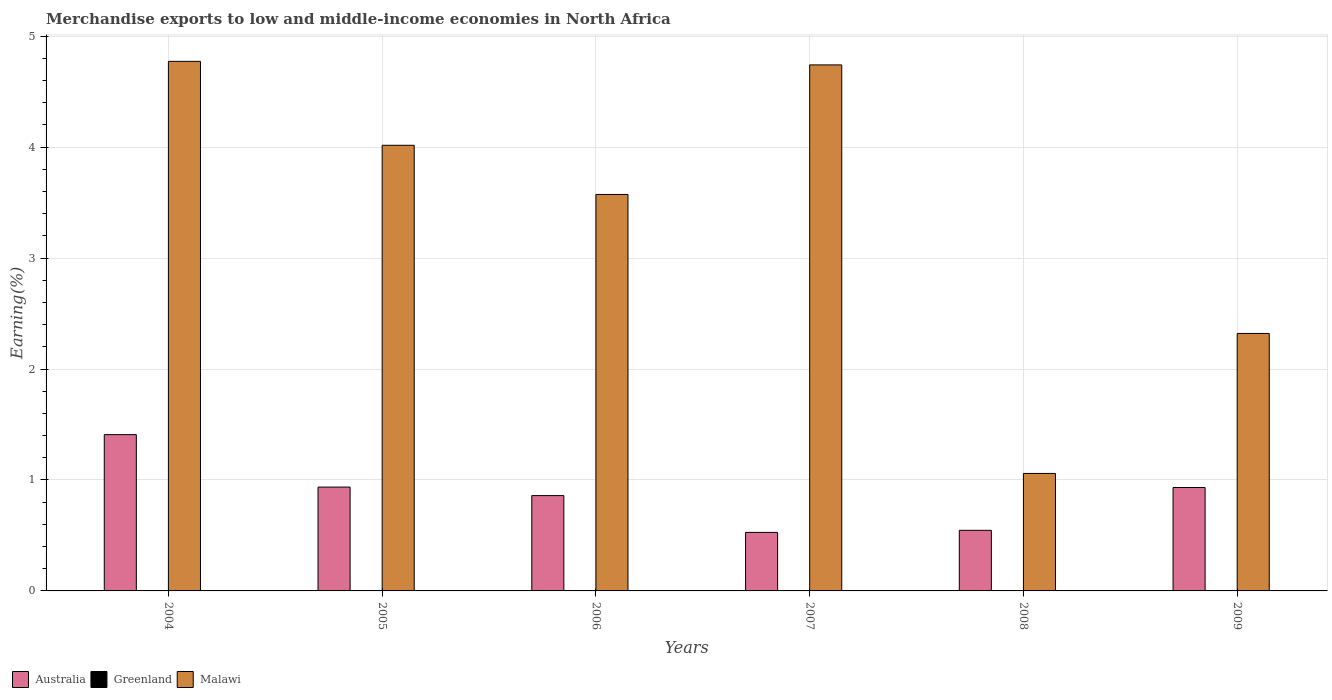Are the number of bars per tick equal to the number of legend labels?
Keep it short and to the point. Yes. Are the number of bars on each tick of the X-axis equal?
Make the answer very short. Yes. In how many cases, is the number of bars for a given year not equal to the number of legend labels?
Give a very brief answer. 0. What is the percentage of amount earned from merchandise exports in Greenland in 2004?
Keep it short and to the point. 2.789635339457349e-5. Across all years, what is the maximum percentage of amount earned from merchandise exports in Australia?
Make the answer very short. 1.41. Across all years, what is the minimum percentage of amount earned from merchandise exports in Greenland?
Make the answer very short. 2.789635339457349e-5. In which year was the percentage of amount earned from merchandise exports in Malawi minimum?
Ensure brevity in your answer.  2008. What is the total percentage of amount earned from merchandise exports in Greenland in the graph?
Provide a short and direct response. 0. What is the difference between the percentage of amount earned from merchandise exports in Malawi in 2008 and that in 2009?
Your response must be concise. -1.26. What is the difference between the percentage of amount earned from merchandise exports in Australia in 2005 and the percentage of amount earned from merchandise exports in Greenland in 2006?
Offer a terse response. 0.94. What is the average percentage of amount earned from merchandise exports in Greenland per year?
Offer a terse response. 0. In the year 2006, what is the difference between the percentage of amount earned from merchandise exports in Australia and percentage of amount earned from merchandise exports in Greenland?
Provide a short and direct response. 0.86. What is the ratio of the percentage of amount earned from merchandise exports in Australia in 2005 to that in 2006?
Your response must be concise. 1.09. What is the difference between the highest and the second highest percentage of amount earned from merchandise exports in Australia?
Offer a terse response. 0.47. What is the difference between the highest and the lowest percentage of amount earned from merchandise exports in Greenland?
Offer a very short reply. 0. In how many years, is the percentage of amount earned from merchandise exports in Malawi greater than the average percentage of amount earned from merchandise exports in Malawi taken over all years?
Your answer should be compact. 4. What does the 1st bar from the left in 2008 represents?
Your response must be concise. Australia. What does the 1st bar from the right in 2009 represents?
Your response must be concise. Malawi. Is it the case that in every year, the sum of the percentage of amount earned from merchandise exports in Malawi and percentage of amount earned from merchandise exports in Australia is greater than the percentage of amount earned from merchandise exports in Greenland?
Your response must be concise. Yes. Are all the bars in the graph horizontal?
Your answer should be compact. No. What is the difference between two consecutive major ticks on the Y-axis?
Your answer should be compact. 1. Are the values on the major ticks of Y-axis written in scientific E-notation?
Your response must be concise. No. Does the graph contain grids?
Your answer should be very brief. Yes. Where does the legend appear in the graph?
Ensure brevity in your answer.  Bottom left. What is the title of the graph?
Your answer should be very brief. Merchandise exports to low and middle-income economies in North Africa. What is the label or title of the Y-axis?
Provide a succinct answer. Earning(%). What is the Earning(%) in Australia in 2004?
Give a very brief answer. 1.41. What is the Earning(%) in Greenland in 2004?
Your answer should be compact. 2.789635339457349e-5. What is the Earning(%) in Malawi in 2004?
Offer a terse response. 4.77. What is the Earning(%) of Australia in 2005?
Ensure brevity in your answer.  0.94. What is the Earning(%) in Greenland in 2005?
Ensure brevity in your answer.  0. What is the Earning(%) in Malawi in 2005?
Keep it short and to the point. 4.02. What is the Earning(%) of Australia in 2006?
Your answer should be compact. 0.86. What is the Earning(%) of Greenland in 2006?
Offer a very short reply. 0. What is the Earning(%) of Malawi in 2006?
Offer a very short reply. 3.57. What is the Earning(%) of Australia in 2007?
Your response must be concise. 0.53. What is the Earning(%) of Greenland in 2007?
Your answer should be compact. 0. What is the Earning(%) of Malawi in 2007?
Provide a short and direct response. 4.74. What is the Earning(%) of Australia in 2008?
Offer a terse response. 0.55. What is the Earning(%) of Greenland in 2008?
Offer a very short reply. 0. What is the Earning(%) of Malawi in 2008?
Keep it short and to the point. 1.06. What is the Earning(%) of Australia in 2009?
Your response must be concise. 0.93. What is the Earning(%) in Greenland in 2009?
Offer a terse response. 0. What is the Earning(%) in Malawi in 2009?
Offer a very short reply. 2.32. Across all years, what is the maximum Earning(%) in Australia?
Offer a terse response. 1.41. Across all years, what is the maximum Earning(%) in Greenland?
Your answer should be compact. 0. Across all years, what is the maximum Earning(%) in Malawi?
Provide a short and direct response. 4.77. Across all years, what is the minimum Earning(%) in Australia?
Offer a terse response. 0.53. Across all years, what is the minimum Earning(%) of Greenland?
Give a very brief answer. 2.789635339457349e-5. Across all years, what is the minimum Earning(%) in Malawi?
Keep it short and to the point. 1.06. What is the total Earning(%) of Australia in the graph?
Your answer should be very brief. 5.21. What is the total Earning(%) in Greenland in the graph?
Give a very brief answer. 0. What is the total Earning(%) of Malawi in the graph?
Make the answer very short. 20.49. What is the difference between the Earning(%) of Australia in 2004 and that in 2005?
Offer a very short reply. 0.47. What is the difference between the Earning(%) in Greenland in 2004 and that in 2005?
Your answer should be compact. -0. What is the difference between the Earning(%) of Malawi in 2004 and that in 2005?
Your answer should be compact. 0.76. What is the difference between the Earning(%) of Australia in 2004 and that in 2006?
Make the answer very short. 0.55. What is the difference between the Earning(%) in Greenland in 2004 and that in 2006?
Offer a terse response. -0. What is the difference between the Earning(%) of Malawi in 2004 and that in 2006?
Your answer should be very brief. 1.2. What is the difference between the Earning(%) in Australia in 2004 and that in 2007?
Give a very brief answer. 0.88. What is the difference between the Earning(%) of Greenland in 2004 and that in 2007?
Provide a succinct answer. -0. What is the difference between the Earning(%) of Malawi in 2004 and that in 2007?
Ensure brevity in your answer.  0.03. What is the difference between the Earning(%) of Australia in 2004 and that in 2008?
Provide a succinct answer. 0.86. What is the difference between the Earning(%) of Greenland in 2004 and that in 2008?
Ensure brevity in your answer.  -0. What is the difference between the Earning(%) in Malawi in 2004 and that in 2008?
Make the answer very short. 3.71. What is the difference between the Earning(%) of Australia in 2004 and that in 2009?
Offer a very short reply. 0.48. What is the difference between the Earning(%) of Greenland in 2004 and that in 2009?
Your answer should be very brief. -0. What is the difference between the Earning(%) in Malawi in 2004 and that in 2009?
Offer a very short reply. 2.45. What is the difference between the Earning(%) of Australia in 2005 and that in 2006?
Your response must be concise. 0.08. What is the difference between the Earning(%) of Greenland in 2005 and that in 2006?
Give a very brief answer. 0. What is the difference between the Earning(%) of Malawi in 2005 and that in 2006?
Your answer should be compact. 0.44. What is the difference between the Earning(%) of Australia in 2005 and that in 2007?
Your answer should be compact. 0.41. What is the difference between the Earning(%) of Greenland in 2005 and that in 2007?
Ensure brevity in your answer.  0. What is the difference between the Earning(%) of Malawi in 2005 and that in 2007?
Make the answer very short. -0.72. What is the difference between the Earning(%) of Australia in 2005 and that in 2008?
Your response must be concise. 0.39. What is the difference between the Earning(%) of Greenland in 2005 and that in 2008?
Offer a terse response. 0. What is the difference between the Earning(%) of Malawi in 2005 and that in 2008?
Offer a terse response. 2.96. What is the difference between the Earning(%) in Australia in 2005 and that in 2009?
Your answer should be very brief. 0. What is the difference between the Earning(%) of Greenland in 2005 and that in 2009?
Provide a short and direct response. 0. What is the difference between the Earning(%) in Malawi in 2005 and that in 2009?
Your answer should be compact. 1.7. What is the difference between the Earning(%) in Australia in 2006 and that in 2007?
Give a very brief answer. 0.33. What is the difference between the Earning(%) of Greenland in 2006 and that in 2007?
Your response must be concise. 0. What is the difference between the Earning(%) of Malawi in 2006 and that in 2007?
Keep it short and to the point. -1.17. What is the difference between the Earning(%) of Australia in 2006 and that in 2008?
Your answer should be very brief. 0.31. What is the difference between the Earning(%) of Greenland in 2006 and that in 2008?
Ensure brevity in your answer.  0. What is the difference between the Earning(%) of Malawi in 2006 and that in 2008?
Provide a succinct answer. 2.51. What is the difference between the Earning(%) in Australia in 2006 and that in 2009?
Offer a very short reply. -0.07. What is the difference between the Earning(%) of Malawi in 2006 and that in 2009?
Offer a terse response. 1.25. What is the difference between the Earning(%) of Australia in 2007 and that in 2008?
Provide a short and direct response. -0.02. What is the difference between the Earning(%) of Malawi in 2007 and that in 2008?
Offer a terse response. 3.68. What is the difference between the Earning(%) in Australia in 2007 and that in 2009?
Offer a terse response. -0.4. What is the difference between the Earning(%) in Malawi in 2007 and that in 2009?
Give a very brief answer. 2.42. What is the difference between the Earning(%) of Australia in 2008 and that in 2009?
Your answer should be compact. -0.39. What is the difference between the Earning(%) in Malawi in 2008 and that in 2009?
Your answer should be compact. -1.26. What is the difference between the Earning(%) in Australia in 2004 and the Earning(%) in Greenland in 2005?
Provide a short and direct response. 1.41. What is the difference between the Earning(%) in Australia in 2004 and the Earning(%) in Malawi in 2005?
Ensure brevity in your answer.  -2.61. What is the difference between the Earning(%) in Greenland in 2004 and the Earning(%) in Malawi in 2005?
Offer a very short reply. -4.02. What is the difference between the Earning(%) of Australia in 2004 and the Earning(%) of Greenland in 2006?
Your answer should be very brief. 1.41. What is the difference between the Earning(%) in Australia in 2004 and the Earning(%) in Malawi in 2006?
Offer a very short reply. -2.16. What is the difference between the Earning(%) of Greenland in 2004 and the Earning(%) of Malawi in 2006?
Your answer should be compact. -3.57. What is the difference between the Earning(%) of Australia in 2004 and the Earning(%) of Greenland in 2007?
Your answer should be compact. 1.41. What is the difference between the Earning(%) of Australia in 2004 and the Earning(%) of Malawi in 2007?
Provide a succinct answer. -3.33. What is the difference between the Earning(%) of Greenland in 2004 and the Earning(%) of Malawi in 2007?
Make the answer very short. -4.74. What is the difference between the Earning(%) in Australia in 2004 and the Earning(%) in Greenland in 2008?
Provide a short and direct response. 1.41. What is the difference between the Earning(%) in Australia in 2004 and the Earning(%) in Malawi in 2008?
Give a very brief answer. 0.35. What is the difference between the Earning(%) in Greenland in 2004 and the Earning(%) in Malawi in 2008?
Ensure brevity in your answer.  -1.06. What is the difference between the Earning(%) of Australia in 2004 and the Earning(%) of Greenland in 2009?
Offer a very short reply. 1.41. What is the difference between the Earning(%) of Australia in 2004 and the Earning(%) of Malawi in 2009?
Your response must be concise. -0.91. What is the difference between the Earning(%) in Greenland in 2004 and the Earning(%) in Malawi in 2009?
Make the answer very short. -2.32. What is the difference between the Earning(%) of Australia in 2005 and the Earning(%) of Greenland in 2006?
Make the answer very short. 0.94. What is the difference between the Earning(%) in Australia in 2005 and the Earning(%) in Malawi in 2006?
Make the answer very short. -2.64. What is the difference between the Earning(%) in Greenland in 2005 and the Earning(%) in Malawi in 2006?
Offer a terse response. -3.57. What is the difference between the Earning(%) in Australia in 2005 and the Earning(%) in Greenland in 2007?
Provide a succinct answer. 0.94. What is the difference between the Earning(%) of Australia in 2005 and the Earning(%) of Malawi in 2007?
Ensure brevity in your answer.  -3.81. What is the difference between the Earning(%) in Greenland in 2005 and the Earning(%) in Malawi in 2007?
Offer a very short reply. -4.74. What is the difference between the Earning(%) in Australia in 2005 and the Earning(%) in Greenland in 2008?
Give a very brief answer. 0.94. What is the difference between the Earning(%) in Australia in 2005 and the Earning(%) in Malawi in 2008?
Offer a terse response. -0.12. What is the difference between the Earning(%) of Greenland in 2005 and the Earning(%) of Malawi in 2008?
Your answer should be very brief. -1.06. What is the difference between the Earning(%) of Australia in 2005 and the Earning(%) of Greenland in 2009?
Keep it short and to the point. 0.94. What is the difference between the Earning(%) in Australia in 2005 and the Earning(%) in Malawi in 2009?
Your response must be concise. -1.38. What is the difference between the Earning(%) of Greenland in 2005 and the Earning(%) of Malawi in 2009?
Ensure brevity in your answer.  -2.32. What is the difference between the Earning(%) in Australia in 2006 and the Earning(%) in Greenland in 2007?
Offer a very short reply. 0.86. What is the difference between the Earning(%) of Australia in 2006 and the Earning(%) of Malawi in 2007?
Offer a terse response. -3.88. What is the difference between the Earning(%) of Greenland in 2006 and the Earning(%) of Malawi in 2007?
Make the answer very short. -4.74. What is the difference between the Earning(%) in Australia in 2006 and the Earning(%) in Greenland in 2008?
Provide a short and direct response. 0.86. What is the difference between the Earning(%) in Australia in 2006 and the Earning(%) in Malawi in 2008?
Offer a very short reply. -0.2. What is the difference between the Earning(%) in Greenland in 2006 and the Earning(%) in Malawi in 2008?
Keep it short and to the point. -1.06. What is the difference between the Earning(%) in Australia in 2006 and the Earning(%) in Greenland in 2009?
Your response must be concise. 0.86. What is the difference between the Earning(%) of Australia in 2006 and the Earning(%) of Malawi in 2009?
Keep it short and to the point. -1.46. What is the difference between the Earning(%) in Greenland in 2006 and the Earning(%) in Malawi in 2009?
Offer a terse response. -2.32. What is the difference between the Earning(%) of Australia in 2007 and the Earning(%) of Greenland in 2008?
Offer a very short reply. 0.53. What is the difference between the Earning(%) of Australia in 2007 and the Earning(%) of Malawi in 2008?
Offer a very short reply. -0.53. What is the difference between the Earning(%) in Greenland in 2007 and the Earning(%) in Malawi in 2008?
Your response must be concise. -1.06. What is the difference between the Earning(%) in Australia in 2007 and the Earning(%) in Greenland in 2009?
Give a very brief answer. 0.53. What is the difference between the Earning(%) of Australia in 2007 and the Earning(%) of Malawi in 2009?
Offer a very short reply. -1.79. What is the difference between the Earning(%) in Greenland in 2007 and the Earning(%) in Malawi in 2009?
Offer a very short reply. -2.32. What is the difference between the Earning(%) in Australia in 2008 and the Earning(%) in Greenland in 2009?
Keep it short and to the point. 0.55. What is the difference between the Earning(%) in Australia in 2008 and the Earning(%) in Malawi in 2009?
Give a very brief answer. -1.77. What is the difference between the Earning(%) in Greenland in 2008 and the Earning(%) in Malawi in 2009?
Your answer should be compact. -2.32. What is the average Earning(%) in Australia per year?
Provide a short and direct response. 0.87. What is the average Earning(%) in Greenland per year?
Provide a short and direct response. 0. What is the average Earning(%) of Malawi per year?
Give a very brief answer. 3.41. In the year 2004, what is the difference between the Earning(%) of Australia and Earning(%) of Greenland?
Offer a terse response. 1.41. In the year 2004, what is the difference between the Earning(%) in Australia and Earning(%) in Malawi?
Give a very brief answer. -3.36. In the year 2004, what is the difference between the Earning(%) in Greenland and Earning(%) in Malawi?
Offer a very short reply. -4.77. In the year 2005, what is the difference between the Earning(%) in Australia and Earning(%) in Greenland?
Ensure brevity in your answer.  0.94. In the year 2005, what is the difference between the Earning(%) of Australia and Earning(%) of Malawi?
Provide a short and direct response. -3.08. In the year 2005, what is the difference between the Earning(%) in Greenland and Earning(%) in Malawi?
Your response must be concise. -4.02. In the year 2006, what is the difference between the Earning(%) of Australia and Earning(%) of Greenland?
Your answer should be very brief. 0.86. In the year 2006, what is the difference between the Earning(%) of Australia and Earning(%) of Malawi?
Give a very brief answer. -2.71. In the year 2006, what is the difference between the Earning(%) in Greenland and Earning(%) in Malawi?
Offer a very short reply. -3.57. In the year 2007, what is the difference between the Earning(%) in Australia and Earning(%) in Greenland?
Keep it short and to the point. 0.53. In the year 2007, what is the difference between the Earning(%) of Australia and Earning(%) of Malawi?
Keep it short and to the point. -4.21. In the year 2007, what is the difference between the Earning(%) in Greenland and Earning(%) in Malawi?
Provide a succinct answer. -4.74. In the year 2008, what is the difference between the Earning(%) of Australia and Earning(%) of Greenland?
Your answer should be compact. 0.55. In the year 2008, what is the difference between the Earning(%) of Australia and Earning(%) of Malawi?
Offer a very short reply. -0.51. In the year 2008, what is the difference between the Earning(%) of Greenland and Earning(%) of Malawi?
Give a very brief answer. -1.06. In the year 2009, what is the difference between the Earning(%) of Australia and Earning(%) of Greenland?
Offer a terse response. 0.93. In the year 2009, what is the difference between the Earning(%) of Australia and Earning(%) of Malawi?
Your response must be concise. -1.39. In the year 2009, what is the difference between the Earning(%) of Greenland and Earning(%) of Malawi?
Your answer should be compact. -2.32. What is the ratio of the Earning(%) of Australia in 2004 to that in 2005?
Ensure brevity in your answer.  1.51. What is the ratio of the Earning(%) of Greenland in 2004 to that in 2005?
Offer a terse response. 0.03. What is the ratio of the Earning(%) of Malawi in 2004 to that in 2005?
Give a very brief answer. 1.19. What is the ratio of the Earning(%) of Australia in 2004 to that in 2006?
Your response must be concise. 1.64. What is the ratio of the Earning(%) of Greenland in 2004 to that in 2006?
Make the answer very short. 0.04. What is the ratio of the Earning(%) of Malawi in 2004 to that in 2006?
Your response must be concise. 1.34. What is the ratio of the Earning(%) of Australia in 2004 to that in 2007?
Your response must be concise. 2.67. What is the ratio of the Earning(%) of Greenland in 2004 to that in 2007?
Offer a terse response. 0.13. What is the ratio of the Earning(%) in Australia in 2004 to that in 2008?
Provide a short and direct response. 2.58. What is the ratio of the Earning(%) of Greenland in 2004 to that in 2008?
Give a very brief answer. 0.11. What is the ratio of the Earning(%) in Malawi in 2004 to that in 2008?
Your answer should be very brief. 4.51. What is the ratio of the Earning(%) in Australia in 2004 to that in 2009?
Give a very brief answer. 1.51. What is the ratio of the Earning(%) in Greenland in 2004 to that in 2009?
Keep it short and to the point. 0.18. What is the ratio of the Earning(%) in Malawi in 2004 to that in 2009?
Keep it short and to the point. 2.06. What is the ratio of the Earning(%) of Australia in 2005 to that in 2006?
Offer a terse response. 1.09. What is the ratio of the Earning(%) in Greenland in 2005 to that in 2006?
Offer a very short reply. 1.24. What is the ratio of the Earning(%) of Malawi in 2005 to that in 2006?
Provide a short and direct response. 1.12. What is the ratio of the Earning(%) of Australia in 2005 to that in 2007?
Give a very brief answer. 1.77. What is the ratio of the Earning(%) in Greenland in 2005 to that in 2007?
Offer a terse response. 4.04. What is the ratio of the Earning(%) in Malawi in 2005 to that in 2007?
Offer a terse response. 0.85. What is the ratio of the Earning(%) in Australia in 2005 to that in 2008?
Offer a terse response. 1.71. What is the ratio of the Earning(%) of Greenland in 2005 to that in 2008?
Provide a short and direct response. 3.4. What is the ratio of the Earning(%) of Malawi in 2005 to that in 2008?
Make the answer very short. 3.79. What is the ratio of the Earning(%) in Greenland in 2005 to that in 2009?
Provide a short and direct response. 5.45. What is the ratio of the Earning(%) in Malawi in 2005 to that in 2009?
Offer a terse response. 1.73. What is the ratio of the Earning(%) of Australia in 2006 to that in 2007?
Offer a very short reply. 1.63. What is the ratio of the Earning(%) of Greenland in 2006 to that in 2007?
Provide a short and direct response. 3.25. What is the ratio of the Earning(%) of Malawi in 2006 to that in 2007?
Ensure brevity in your answer.  0.75. What is the ratio of the Earning(%) of Australia in 2006 to that in 2008?
Provide a succinct answer. 1.57. What is the ratio of the Earning(%) of Greenland in 2006 to that in 2008?
Offer a very short reply. 2.73. What is the ratio of the Earning(%) in Malawi in 2006 to that in 2008?
Provide a succinct answer. 3.37. What is the ratio of the Earning(%) in Australia in 2006 to that in 2009?
Offer a very short reply. 0.92. What is the ratio of the Earning(%) of Greenland in 2006 to that in 2009?
Your answer should be very brief. 4.38. What is the ratio of the Earning(%) of Malawi in 2006 to that in 2009?
Your response must be concise. 1.54. What is the ratio of the Earning(%) in Australia in 2007 to that in 2008?
Give a very brief answer. 0.97. What is the ratio of the Earning(%) in Greenland in 2007 to that in 2008?
Your response must be concise. 0.84. What is the ratio of the Earning(%) in Malawi in 2007 to that in 2008?
Offer a terse response. 4.48. What is the ratio of the Earning(%) in Australia in 2007 to that in 2009?
Provide a succinct answer. 0.57. What is the ratio of the Earning(%) of Greenland in 2007 to that in 2009?
Make the answer very short. 1.35. What is the ratio of the Earning(%) of Malawi in 2007 to that in 2009?
Your answer should be very brief. 2.04. What is the ratio of the Earning(%) in Australia in 2008 to that in 2009?
Ensure brevity in your answer.  0.59. What is the ratio of the Earning(%) of Greenland in 2008 to that in 2009?
Your answer should be compact. 1.6. What is the ratio of the Earning(%) of Malawi in 2008 to that in 2009?
Provide a succinct answer. 0.46. What is the difference between the highest and the second highest Earning(%) of Australia?
Keep it short and to the point. 0.47. What is the difference between the highest and the second highest Earning(%) of Malawi?
Provide a succinct answer. 0.03. What is the difference between the highest and the lowest Earning(%) of Australia?
Your answer should be compact. 0.88. What is the difference between the highest and the lowest Earning(%) of Greenland?
Your answer should be very brief. 0. What is the difference between the highest and the lowest Earning(%) of Malawi?
Ensure brevity in your answer.  3.71. 